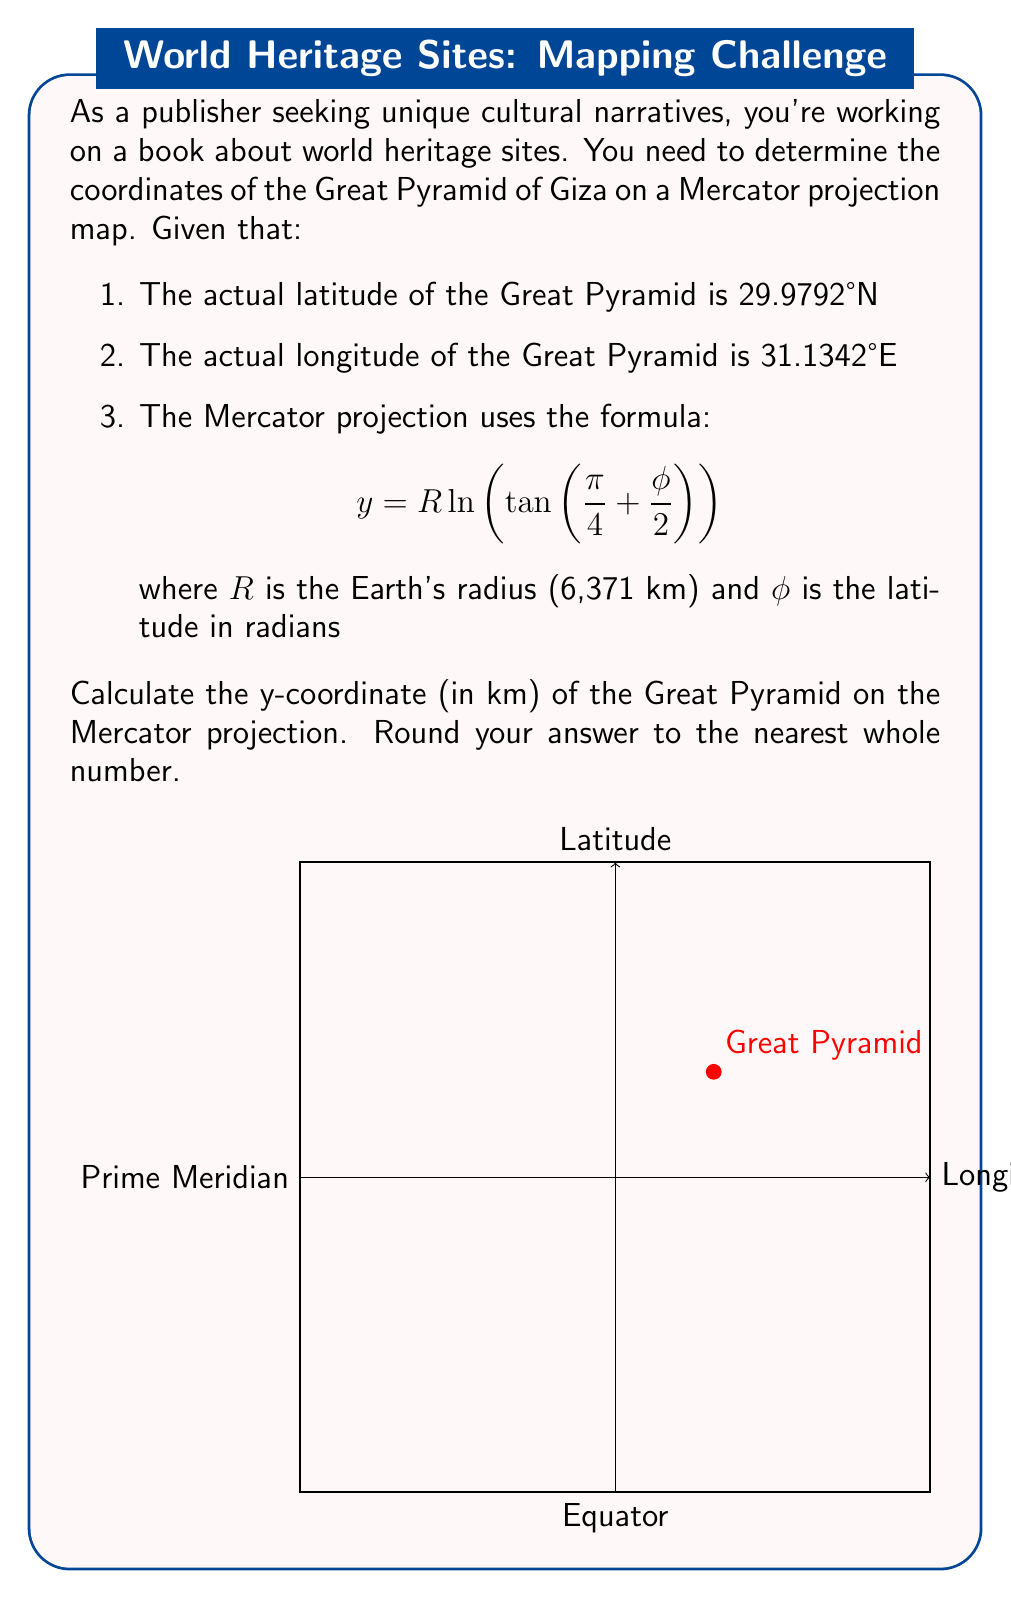Show me your answer to this math problem. To solve this problem, we'll follow these steps:

1. Convert the latitude from degrees to radians:
   $\phi = 29.9792° \times \frac{\pi}{180} = 0.5232$ radians

2. Apply the Mercator projection formula:
   $$y = R \ln(\tan(\frac{\pi}{4} + \frac{\phi}{2}))$$

3. Substitute the values:
   $R = 6,371$ km
   $\phi = 0.5232$ radians

   $$y = 6,371 \times \ln(\tan(\frac{\pi}{4} + \frac{0.5232}{2}))$$

4. Calculate the result:
   $$y = 6,371 \times \ln(\tan(1.0478))$$
   $$y = 6,371 \times \ln(2.5645)$$
   $$y = 6,371 \times 0.9417$$
   $$y = 5,999.6407$$ km

5. Round to the nearest whole number:
   $y \approx 6,000$ km

The x-coordinate on the Mercator projection is simply the longitude scaled by the Earth's radius:
$x = R \times \text{longitude in radians} = 6,371 \times (31.1342° \times \frac{\pi}{180}) = 3,464$ km

Therefore, the coordinates of the Great Pyramid on the Mercator projection are approximately (3464 km, 6000 km).
Answer: 6000 km 